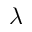<formula> <loc_0><loc_0><loc_500><loc_500>\lambda</formula> 